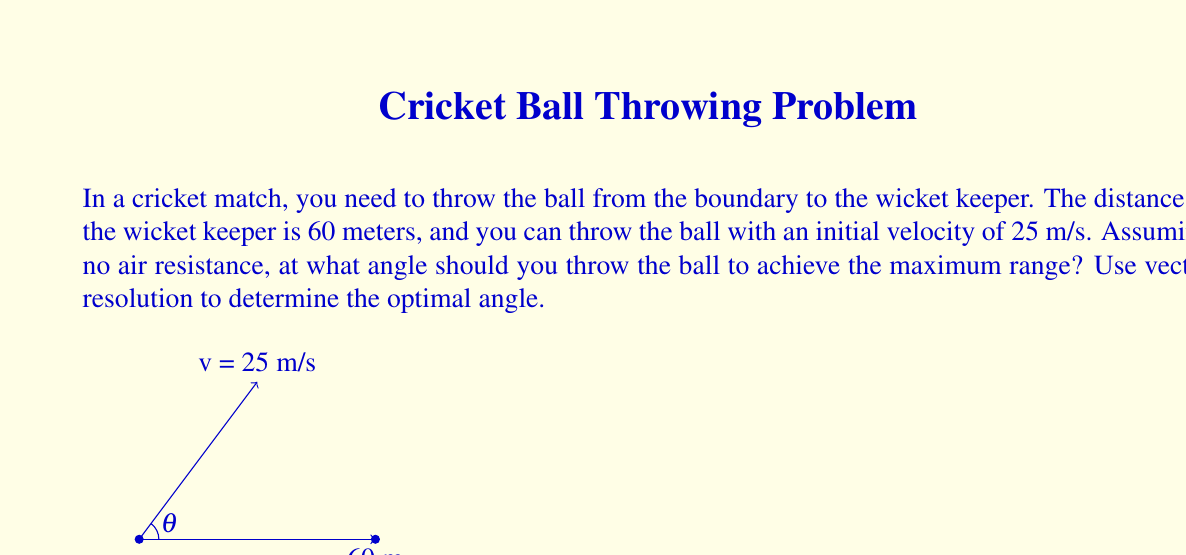Solve this math problem. To determine the optimal angle for maximum range, we'll use vector resolution and the equations of projectile motion. Let's break this down step-by-step:

1) The initial velocity vector can be resolved into horizontal and vertical components:
   $v_x = v \cos\theta$
   $v_y = v \sin\theta$

2) The time of flight for the projectile is given by:
   $t = \frac{2v_y}{g} = \frac{2v\sin\theta}{g}$

3) The range (R) of the projectile is given by:
   $R = v_x t = (v\cos\theta)(\frac{2v\sin\theta}{g})$

4) Simplifying:
   $R = \frac{2v^2\sin\theta\cos\theta}{g}$

5) Using the trigonometric identity $\sin 2\theta = 2\sin\theta\cos\theta$, we get:
   $R = \frac{v^2\sin 2\theta}{g}$

6) To find the maximum range, we need to maximize $\sin 2\theta$. This occurs when $2\theta = 90°$, or when $\theta = 45°$.

7) Therefore, the optimal angle for maximum range is 45°.

8) We can verify this by calculating the range:
   $R = \frac{(25 \text{ m/s})^2 \sin(2 \cdot 45°)}{9.8 \text{ m/s}^2} \approx 63.78 \text{ m}$

This is slightly more than the required 60 meters, ensuring the ball reaches the wicket keeper.
Answer: 45° 